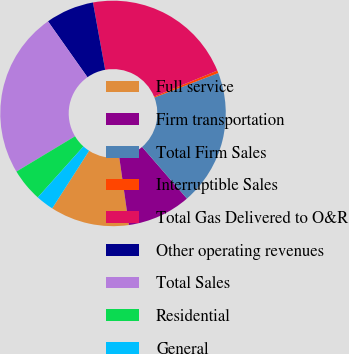Convert chart to OTSL. <chart><loc_0><loc_0><loc_500><loc_500><pie_chart><fcel>Full service<fcel>Firm transportation<fcel>Total Firm Sales<fcel>Interruptible Sales<fcel>Total Gas Delivered to O&R<fcel>Other operating revenues<fcel>Total Sales<fcel>Residential<fcel>General<nl><fcel>11.32%<fcel>9.13%<fcel>19.46%<fcel>0.37%<fcel>21.65%<fcel>6.94%<fcel>23.84%<fcel>4.75%<fcel>2.56%<nl></chart> 